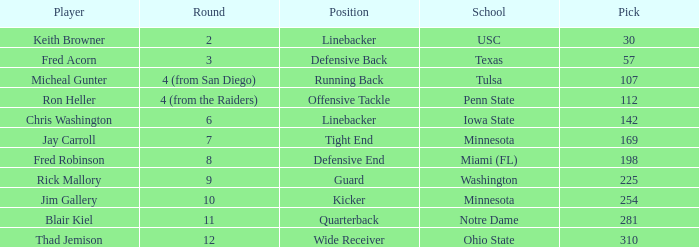What is the highest pick from Washington? 225.0. 